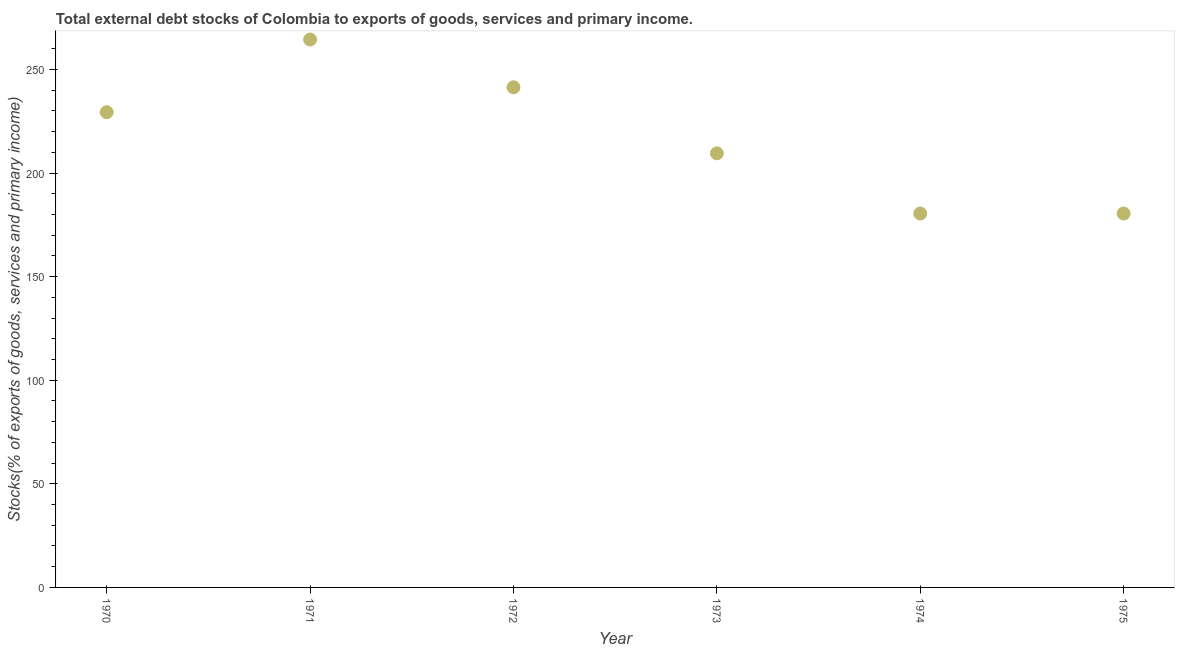What is the external debt stocks in 1971?
Provide a succinct answer. 264.42. Across all years, what is the maximum external debt stocks?
Make the answer very short. 264.42. Across all years, what is the minimum external debt stocks?
Your response must be concise. 180.45. In which year was the external debt stocks maximum?
Your response must be concise. 1971. In which year was the external debt stocks minimum?
Keep it short and to the point. 1974. What is the sum of the external debt stocks?
Your answer should be compact. 1305.55. What is the difference between the external debt stocks in 1970 and 1971?
Your answer should be very brief. -35.07. What is the average external debt stocks per year?
Provide a short and direct response. 217.59. What is the median external debt stocks?
Offer a very short reply. 219.42. In how many years, is the external debt stocks greater than 160 %?
Provide a succinct answer. 6. What is the ratio of the external debt stocks in 1974 to that in 1975?
Your answer should be compact. 1. Is the external debt stocks in 1970 less than that in 1974?
Provide a succinct answer. No. Is the difference between the external debt stocks in 1973 and 1974 greater than the difference between any two years?
Make the answer very short. No. What is the difference between the highest and the second highest external debt stocks?
Offer a very short reply. 23.04. Is the sum of the external debt stocks in 1972 and 1974 greater than the maximum external debt stocks across all years?
Offer a very short reply. Yes. What is the difference between the highest and the lowest external debt stocks?
Provide a short and direct response. 83.97. In how many years, is the external debt stocks greater than the average external debt stocks taken over all years?
Provide a succinct answer. 3. How many years are there in the graph?
Your response must be concise. 6. What is the difference between two consecutive major ticks on the Y-axis?
Keep it short and to the point. 50. Are the values on the major ticks of Y-axis written in scientific E-notation?
Keep it short and to the point. No. Does the graph contain grids?
Provide a succinct answer. No. What is the title of the graph?
Make the answer very short. Total external debt stocks of Colombia to exports of goods, services and primary income. What is the label or title of the Y-axis?
Your answer should be very brief. Stocks(% of exports of goods, services and primary income). What is the Stocks(% of exports of goods, services and primary income) in 1970?
Your response must be concise. 229.35. What is the Stocks(% of exports of goods, services and primary income) in 1971?
Make the answer very short. 264.42. What is the Stocks(% of exports of goods, services and primary income) in 1972?
Your answer should be compact. 241.37. What is the Stocks(% of exports of goods, services and primary income) in 1973?
Provide a succinct answer. 209.5. What is the Stocks(% of exports of goods, services and primary income) in 1974?
Keep it short and to the point. 180.45. What is the Stocks(% of exports of goods, services and primary income) in 1975?
Offer a very short reply. 180.46. What is the difference between the Stocks(% of exports of goods, services and primary income) in 1970 and 1971?
Your answer should be compact. -35.07. What is the difference between the Stocks(% of exports of goods, services and primary income) in 1970 and 1972?
Provide a succinct answer. -12.02. What is the difference between the Stocks(% of exports of goods, services and primary income) in 1970 and 1973?
Make the answer very short. 19.85. What is the difference between the Stocks(% of exports of goods, services and primary income) in 1970 and 1974?
Your response must be concise. 48.9. What is the difference between the Stocks(% of exports of goods, services and primary income) in 1970 and 1975?
Offer a very short reply. 48.89. What is the difference between the Stocks(% of exports of goods, services and primary income) in 1971 and 1972?
Your response must be concise. 23.04. What is the difference between the Stocks(% of exports of goods, services and primary income) in 1971 and 1973?
Give a very brief answer. 54.92. What is the difference between the Stocks(% of exports of goods, services and primary income) in 1971 and 1974?
Keep it short and to the point. 83.97. What is the difference between the Stocks(% of exports of goods, services and primary income) in 1971 and 1975?
Provide a succinct answer. 83.96. What is the difference between the Stocks(% of exports of goods, services and primary income) in 1972 and 1973?
Offer a terse response. 31.87. What is the difference between the Stocks(% of exports of goods, services and primary income) in 1972 and 1974?
Make the answer very short. 60.92. What is the difference between the Stocks(% of exports of goods, services and primary income) in 1972 and 1975?
Offer a very short reply. 60.91. What is the difference between the Stocks(% of exports of goods, services and primary income) in 1973 and 1974?
Your answer should be very brief. 29.05. What is the difference between the Stocks(% of exports of goods, services and primary income) in 1973 and 1975?
Your answer should be very brief. 29.04. What is the difference between the Stocks(% of exports of goods, services and primary income) in 1974 and 1975?
Provide a short and direct response. -0.01. What is the ratio of the Stocks(% of exports of goods, services and primary income) in 1970 to that in 1971?
Offer a very short reply. 0.87. What is the ratio of the Stocks(% of exports of goods, services and primary income) in 1970 to that in 1972?
Make the answer very short. 0.95. What is the ratio of the Stocks(% of exports of goods, services and primary income) in 1970 to that in 1973?
Your answer should be compact. 1.09. What is the ratio of the Stocks(% of exports of goods, services and primary income) in 1970 to that in 1974?
Provide a succinct answer. 1.27. What is the ratio of the Stocks(% of exports of goods, services and primary income) in 1970 to that in 1975?
Make the answer very short. 1.27. What is the ratio of the Stocks(% of exports of goods, services and primary income) in 1971 to that in 1972?
Offer a terse response. 1.09. What is the ratio of the Stocks(% of exports of goods, services and primary income) in 1971 to that in 1973?
Offer a very short reply. 1.26. What is the ratio of the Stocks(% of exports of goods, services and primary income) in 1971 to that in 1974?
Your answer should be very brief. 1.47. What is the ratio of the Stocks(% of exports of goods, services and primary income) in 1971 to that in 1975?
Offer a terse response. 1.47. What is the ratio of the Stocks(% of exports of goods, services and primary income) in 1972 to that in 1973?
Give a very brief answer. 1.15. What is the ratio of the Stocks(% of exports of goods, services and primary income) in 1972 to that in 1974?
Keep it short and to the point. 1.34. What is the ratio of the Stocks(% of exports of goods, services and primary income) in 1972 to that in 1975?
Offer a terse response. 1.34. What is the ratio of the Stocks(% of exports of goods, services and primary income) in 1973 to that in 1974?
Keep it short and to the point. 1.16. What is the ratio of the Stocks(% of exports of goods, services and primary income) in 1973 to that in 1975?
Provide a short and direct response. 1.16. 